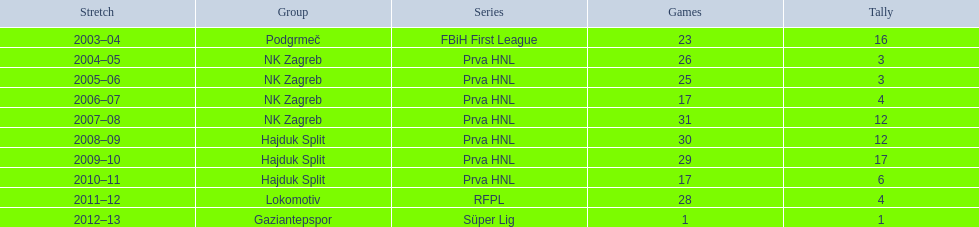Did ibricic score more or less goals in his 3 seasons with hajduk split when compared to his 4 seasons with nk zagreb? More. Give me the full table as a dictionary. {'header': ['Stretch', 'Group', 'Series', 'Games', 'Tally'], 'rows': [['2003–04', 'Podgrmeč', 'FBiH First League', '23', '16'], ['2004–05', 'NK Zagreb', 'Prva HNL', '26', '3'], ['2005–06', 'NK Zagreb', 'Prva HNL', '25', '3'], ['2006–07', 'NK Zagreb', 'Prva HNL', '17', '4'], ['2007–08', 'NK Zagreb', 'Prva HNL', '31', '12'], ['2008–09', 'Hajduk Split', 'Prva HNL', '30', '12'], ['2009–10', 'Hajduk Split', 'Prva HNL', '29', '17'], ['2010–11', 'Hajduk Split', 'Prva HNL', '17', '6'], ['2011–12', 'Lokomotiv', 'RFPL', '28', '4'], ['2012–13', 'Gaziantepspor', 'Süper Lig', '1', '1']]} 